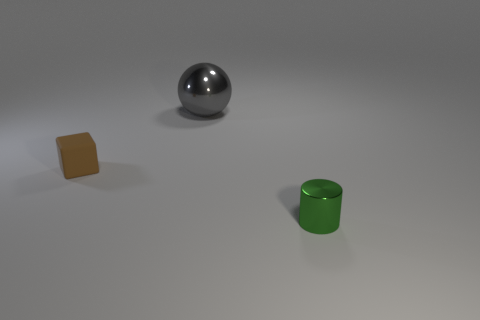Are there fewer purple blocks than small green objects?
Offer a terse response. Yes. There is a thing that is right of the tiny brown rubber cube and behind the small green metallic cylinder; what color is it?
Your response must be concise. Gray. Is there anything else that has the same size as the sphere?
Your answer should be very brief. No. Are there more tiny brown blocks than metal objects?
Offer a terse response. No. There is a thing that is both in front of the large metallic object and to the right of the tiny brown matte thing; how big is it?
Offer a very short reply. Small. What shape is the small green metal thing?
Provide a short and direct response. Cylinder. Is the number of cylinders that are in front of the small green object less than the number of big gray metal spheres in front of the gray shiny sphere?
Your answer should be very brief. No. There is a tiny object in front of the matte thing; how many things are left of it?
Your answer should be very brief. 2. Are any large green shiny spheres visible?
Give a very brief answer. No. Is there a small green object that has the same material as the large object?
Provide a succinct answer. Yes. 